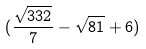<formula> <loc_0><loc_0><loc_500><loc_500>( \frac { \sqrt { 3 3 2 } } { 7 } - \sqrt { 8 1 } + 6 )</formula> 